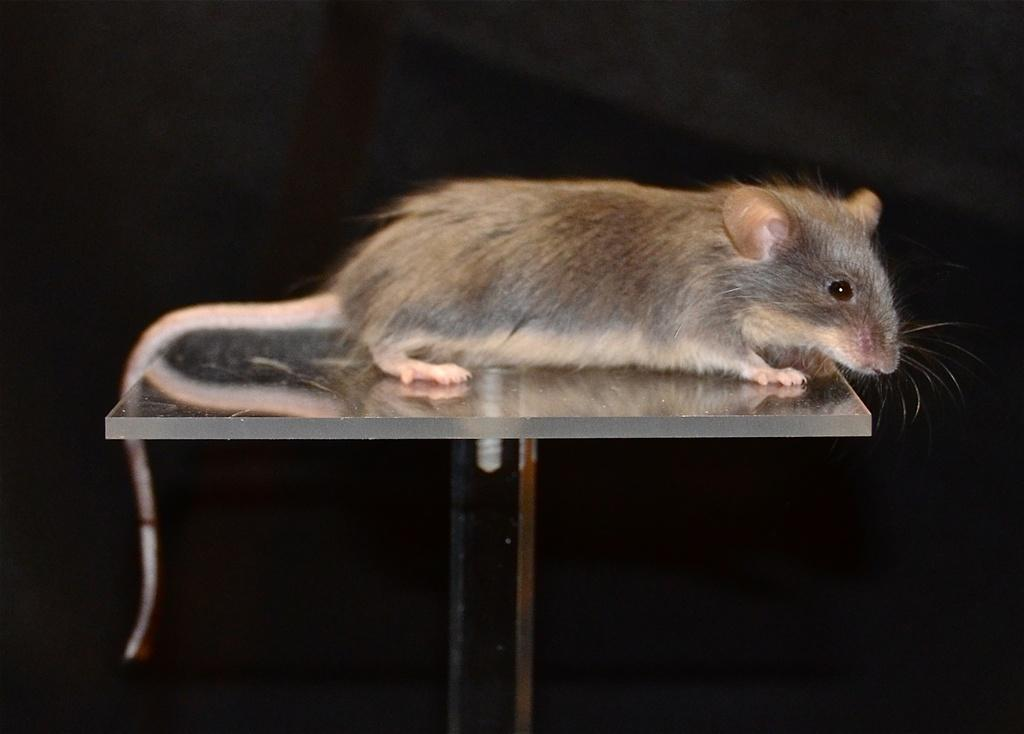What animal is on the table in the image? There is a rat on the table in the image. What can be observed about the lighting in the image? The background of the image is dark. How many ornaments are on the rat's feet in the image? There are no ornaments present on the rat's feet in the image, as the rat is not wearing any. 